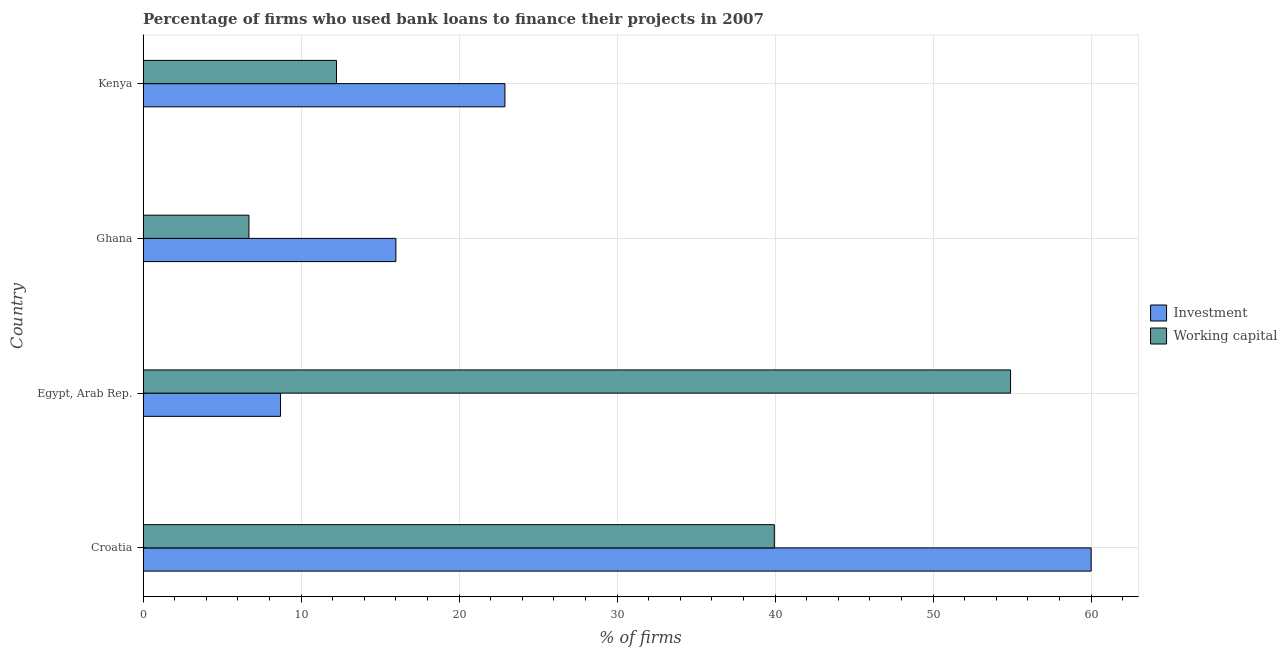Are the number of bars per tick equal to the number of legend labels?
Your response must be concise. Yes. Are the number of bars on each tick of the Y-axis equal?
Ensure brevity in your answer.  Yes. How many bars are there on the 4th tick from the top?
Offer a very short reply. 2. How many bars are there on the 3rd tick from the bottom?
Ensure brevity in your answer.  2. What is the label of the 3rd group of bars from the top?
Keep it short and to the point. Egypt, Arab Rep. In how many cases, is the number of bars for a given country not equal to the number of legend labels?
Keep it short and to the point. 0. What is the percentage of firms using banks to finance investment in Croatia?
Give a very brief answer. 60. Across all countries, what is the maximum percentage of firms using banks to finance investment?
Give a very brief answer. 60. Across all countries, what is the minimum percentage of firms using banks to finance working capital?
Give a very brief answer. 6.7. In which country was the percentage of firms using banks to finance working capital maximum?
Keep it short and to the point. Egypt, Arab Rep. In which country was the percentage of firms using banks to finance investment minimum?
Ensure brevity in your answer.  Egypt, Arab Rep. What is the total percentage of firms using banks to finance investment in the graph?
Give a very brief answer. 107.6. What is the difference between the percentage of firms using banks to finance working capital in Croatia and that in Egypt, Arab Rep.?
Keep it short and to the point. -14.95. What is the difference between the percentage of firms using banks to finance working capital in Kenya and the percentage of firms using banks to finance investment in Egypt, Arab Rep.?
Offer a terse response. 3.54. What is the average percentage of firms using banks to finance working capital per country?
Your answer should be very brief. 28.45. What is the difference between the percentage of firms using banks to finance working capital and percentage of firms using banks to finance investment in Kenya?
Keep it short and to the point. -10.66. In how many countries, is the percentage of firms using banks to finance working capital greater than 38 %?
Provide a succinct answer. 2. What is the ratio of the percentage of firms using banks to finance investment in Egypt, Arab Rep. to that in Kenya?
Keep it short and to the point. 0.38. Is the difference between the percentage of firms using banks to finance investment in Croatia and Ghana greater than the difference between the percentage of firms using banks to finance working capital in Croatia and Ghana?
Keep it short and to the point. Yes. What is the difference between the highest and the second highest percentage of firms using banks to finance investment?
Offer a terse response. 37.1. What is the difference between the highest and the lowest percentage of firms using banks to finance investment?
Ensure brevity in your answer.  51.3. What does the 2nd bar from the top in Egypt, Arab Rep. represents?
Make the answer very short. Investment. What does the 2nd bar from the bottom in Egypt, Arab Rep. represents?
Provide a short and direct response. Working capital. Are all the bars in the graph horizontal?
Keep it short and to the point. Yes. How many countries are there in the graph?
Provide a succinct answer. 4. What is the difference between two consecutive major ticks on the X-axis?
Offer a terse response. 10. Are the values on the major ticks of X-axis written in scientific E-notation?
Your answer should be very brief. No. Does the graph contain any zero values?
Provide a short and direct response. No. Does the graph contain grids?
Ensure brevity in your answer.  Yes. How many legend labels are there?
Your answer should be compact. 2. How are the legend labels stacked?
Offer a terse response. Vertical. What is the title of the graph?
Ensure brevity in your answer.  Percentage of firms who used bank loans to finance their projects in 2007. Does "DAC donors" appear as one of the legend labels in the graph?
Offer a terse response. No. What is the label or title of the X-axis?
Your response must be concise. % of firms. What is the label or title of the Y-axis?
Offer a terse response. Country. What is the % of firms of Working capital in Croatia?
Provide a short and direct response. 39.95. What is the % of firms of Working capital in Egypt, Arab Rep.?
Offer a very short reply. 54.9. What is the % of firms of Investment in Kenya?
Offer a terse response. 22.9. What is the % of firms of Working capital in Kenya?
Your answer should be very brief. 12.24. Across all countries, what is the maximum % of firms of Working capital?
Your response must be concise. 54.9. Across all countries, what is the minimum % of firms of Working capital?
Your response must be concise. 6.7. What is the total % of firms of Investment in the graph?
Give a very brief answer. 107.6. What is the total % of firms in Working capital in the graph?
Offer a very short reply. 113.79. What is the difference between the % of firms in Investment in Croatia and that in Egypt, Arab Rep.?
Offer a terse response. 51.3. What is the difference between the % of firms in Working capital in Croatia and that in Egypt, Arab Rep.?
Ensure brevity in your answer.  -14.95. What is the difference between the % of firms in Working capital in Croatia and that in Ghana?
Provide a succinct answer. 33.25. What is the difference between the % of firms in Investment in Croatia and that in Kenya?
Your response must be concise. 37.1. What is the difference between the % of firms in Working capital in Croatia and that in Kenya?
Your response must be concise. 27.71. What is the difference between the % of firms of Investment in Egypt, Arab Rep. and that in Ghana?
Your response must be concise. -7.3. What is the difference between the % of firms of Working capital in Egypt, Arab Rep. and that in Ghana?
Your answer should be compact. 48.2. What is the difference between the % of firms of Working capital in Egypt, Arab Rep. and that in Kenya?
Make the answer very short. 42.66. What is the difference between the % of firms of Investment in Ghana and that in Kenya?
Your answer should be very brief. -6.9. What is the difference between the % of firms of Working capital in Ghana and that in Kenya?
Make the answer very short. -5.54. What is the difference between the % of firms in Investment in Croatia and the % of firms in Working capital in Ghana?
Your answer should be compact. 53.3. What is the difference between the % of firms in Investment in Croatia and the % of firms in Working capital in Kenya?
Provide a succinct answer. 47.76. What is the difference between the % of firms of Investment in Egypt, Arab Rep. and the % of firms of Working capital in Ghana?
Provide a succinct answer. 2. What is the difference between the % of firms in Investment in Egypt, Arab Rep. and the % of firms in Working capital in Kenya?
Your response must be concise. -3.54. What is the difference between the % of firms in Investment in Ghana and the % of firms in Working capital in Kenya?
Provide a short and direct response. 3.76. What is the average % of firms of Investment per country?
Offer a very short reply. 26.9. What is the average % of firms of Working capital per country?
Make the answer very short. 28.45. What is the difference between the % of firms of Investment and % of firms of Working capital in Croatia?
Your answer should be very brief. 20.05. What is the difference between the % of firms in Investment and % of firms in Working capital in Egypt, Arab Rep.?
Your answer should be very brief. -46.2. What is the difference between the % of firms in Investment and % of firms in Working capital in Ghana?
Your answer should be very brief. 9.3. What is the difference between the % of firms in Investment and % of firms in Working capital in Kenya?
Offer a terse response. 10.66. What is the ratio of the % of firms of Investment in Croatia to that in Egypt, Arab Rep.?
Provide a short and direct response. 6.9. What is the ratio of the % of firms in Working capital in Croatia to that in Egypt, Arab Rep.?
Keep it short and to the point. 0.73. What is the ratio of the % of firms of Investment in Croatia to that in Ghana?
Give a very brief answer. 3.75. What is the ratio of the % of firms in Working capital in Croatia to that in Ghana?
Your response must be concise. 5.96. What is the ratio of the % of firms of Investment in Croatia to that in Kenya?
Your response must be concise. 2.62. What is the ratio of the % of firms in Working capital in Croatia to that in Kenya?
Offer a terse response. 3.26. What is the ratio of the % of firms in Investment in Egypt, Arab Rep. to that in Ghana?
Offer a very short reply. 0.54. What is the ratio of the % of firms in Working capital in Egypt, Arab Rep. to that in Ghana?
Offer a terse response. 8.19. What is the ratio of the % of firms of Investment in Egypt, Arab Rep. to that in Kenya?
Make the answer very short. 0.38. What is the ratio of the % of firms of Working capital in Egypt, Arab Rep. to that in Kenya?
Give a very brief answer. 4.49. What is the ratio of the % of firms of Investment in Ghana to that in Kenya?
Offer a very short reply. 0.7. What is the ratio of the % of firms in Working capital in Ghana to that in Kenya?
Offer a very short reply. 0.55. What is the difference between the highest and the second highest % of firms of Investment?
Offer a terse response. 37.1. What is the difference between the highest and the second highest % of firms in Working capital?
Provide a short and direct response. 14.95. What is the difference between the highest and the lowest % of firms in Investment?
Provide a short and direct response. 51.3. What is the difference between the highest and the lowest % of firms in Working capital?
Ensure brevity in your answer.  48.2. 